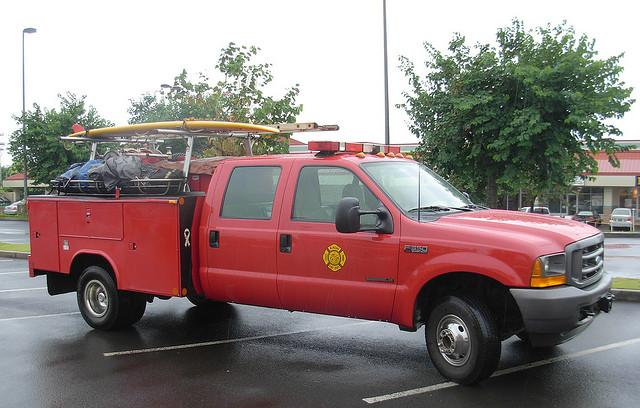What is this vehicle used for? emergencies 